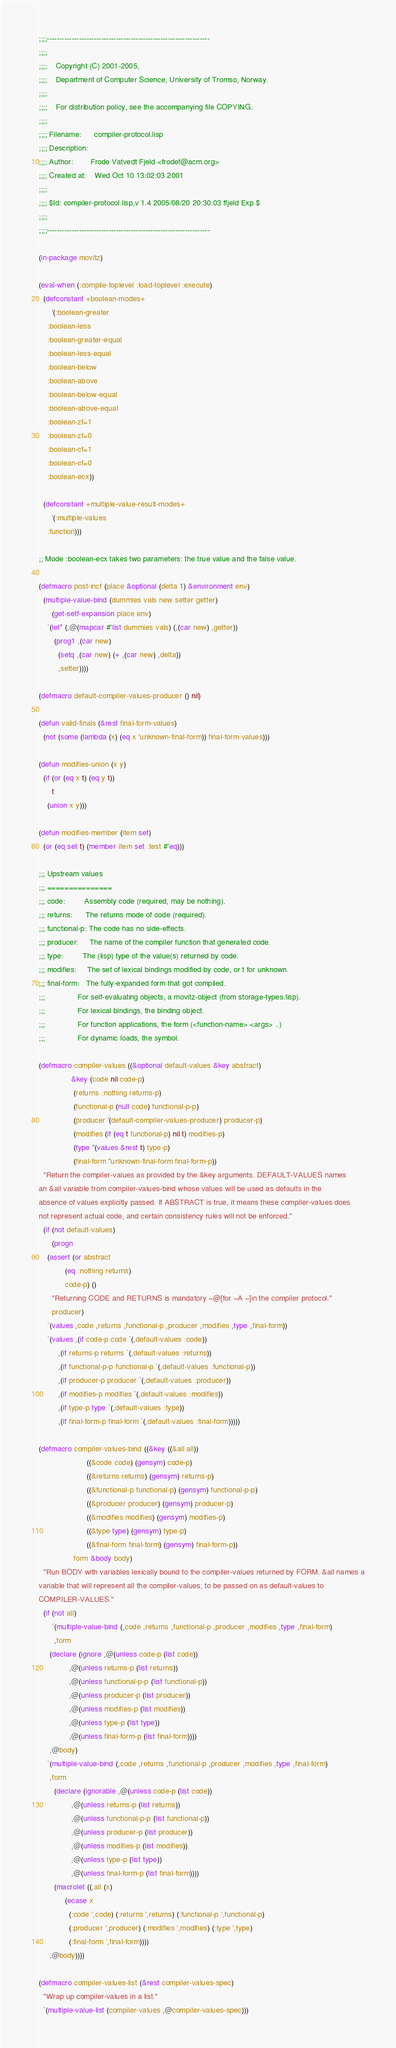Convert code to text. <code><loc_0><loc_0><loc_500><loc_500><_Lisp_>;;;;------------------------------------------------------------------
;;;; 
;;;;    Copyright (C) 2001-2005, 
;;;;    Department of Computer Science, University of Tromso, Norway.
;;;; 
;;;;    For distribution policy, see the accompanying file COPYING.
;;;; 
;;;; Filename:      compiler-protocol.lisp
;;;; Description:   
;;;; Author:        Frode Vatvedt Fjeld <frodef@acm.org>
;;;; Created at:    Wed Oct 10 13:02:03 2001
;;;;                
;;;; $Id: compiler-protocol.lisp,v 1.4 2005/08/20 20:30:03 ffjeld Exp $
;;;;                
;;;;------------------------------------------------------------------

(in-package movitz)

(eval-when (:compile-toplevel :load-toplevel :execute)
  (defconstant +boolean-modes+
      '(:boolean-greater
	:boolean-less
	:boolean-greater-equal
	:boolean-less-equal
	:boolean-below
	:boolean-above
	:boolean-below-equal
	:boolean-above-equal
	:boolean-zf=1
	:boolean-zf=0
	:boolean-cf=1
	:boolean-cf=0
	:boolean-ecx))
  
  (defconstant +multiple-value-result-modes+
      '(:multiple-values
	:function)))

;; Mode :boolean-ecx takes two parameters: the true value and the false value.

(defmacro post-incf (place &optional (delta 1) &environment env)
  (multiple-value-bind (dummies vals new setter getter)
      (get-setf-expansion place env)
    `(let* (,@(mapcar #'list dummies vals) (,(car new) ,getter))
       (prog1 ,(car new)
         (setq ,(car new) (+ ,(car new) ,delta))
         ,setter))))

(defmacro default-compiler-values-producer () nil)

(defun valid-finals (&rest final-form-values)
  (not (some (lambda (x) (eq x 'unknown-final-form)) final-form-values)))

(defun modifies-union (x y)
  (if (or (eq x t) (eq y t))
      t
    (union x y)))

(defun modifies-member (item set)
  (or (eq set t) (member item set :test #'eq)))

;;; Upstream values
;;; ===============
;;; code:         Assembly code (required, may be nothing).
;;; returns:      The returns mode of code (required).
;;; functional-p: The code has no side-effects.
;;; producer:     The name of the compiler function that generated code.
;;; type:         The (lisp) type of the value(s) returned by code.
;;; modifies:     The set of lexical bindings modified by code, or t for unknown.
;;; final-form:   The fully-expanded form that got compiled.
;;;               For self-evaluating objects, a movitz-object (from storage-types.lisp).
;;;               For lexical bindings, the binding object.
;;;               For function applications, the form (<function-name> <args> ..)
;;;               For dynamic loads, the symbol.

(defmacro compiler-values ((&optional default-values &key abstract)
			   &key (code nil code-p)
				(returns :nothing returns-p)
				(functional-p (null code) functional-p-p)
				(producer '(default-compiler-values-producer) producer-p)
				(modifies (if (eq t functional-p) nil t) modifies-p)
				(type ''(values &rest t) type-p)
				(final-form ''unknown-final-form final-form-p))
  "Return the compiler-values as provided by the &key arguments. DEFAULT-VALUES names
an &all variable from compiler-values-bind whose values will be used as defaults in the
absence of values explicitly passed. If ABSTRACT is true, it means these compiler-values does
not represent actual code, and certain consistency rules will not be enforced."
  (if (not default-values)
      (progn
	(assert (or abstract
		    (eq :nothing returns)
		    code-p) ()
	  "Returning CODE and RETURNS is mandatory ~@[for ~A ~]in the compiler protocol."
	  producer)
	`(values ,code ,returns ,functional-p ,producer ,modifies ,type ,final-form))
    `(values ,(if code-p code `(,default-values :code))
	     ,(if returns-p returns `(,default-values :returns))
	     ,(if functional-p-p functional-p `(,default-values :functional-p))
	     ,(if producer-p producer `(,default-values :producer))
	     ,(if modifies-p modifies `(,default-values :modifies))
	     ,(if type-p type `(,default-values :type))
	     ,(if final-form-p final-form `(,default-values :final-form)))))

(defmacro compiler-values-bind ((&key ((&all all))
				      ((&code code) (gensym) code-p)
				      ((&returns returns) (gensym) returns-p)
				      ((&functional-p functional-p) (gensym) functional-p-p)
				      ((&producer producer) (gensym) producer-p)
				      ((&modifies modifies) (gensym) modifies-p)
				      ((&type type) (gensym) type-p)
				      ((&final-form final-form) (gensym) final-form-p))
				form &body body)
  "Run BODY with variables lexically bound to the compiler-values returned by FORM. &all names a
variable that will represent all the compiler-values, to be passed on as default-values to
COMPILER-VALUES."
  (if (not all)
      `(multiple-value-bind (,code ,returns ,functional-p ,producer ,modifies ,type ,final-form)
	   ,form
	 (declare (ignore ,@(unless code-p (list code))
			  ,@(unless returns-p (list returns))
			  ,@(unless functional-p-p (list functional-p))
			  ,@(unless producer-p (list producer))
			  ,@(unless modifies-p (list modifies))
			  ,@(unless type-p (list type))
			  ,@(unless final-form-p (list final-form))))
	 ,@body)
    `(multiple-value-bind (,code ,returns ,functional-p ,producer ,modifies ,type ,final-form)
	 ,form
       (declare (ignorable ,@(unless code-p (list code))
			   ,@(unless returns-p (list returns))
			   ,@(unless functional-p-p (list functional-p))
			   ,@(unless producer-p (list producer))
			   ,@(unless modifies-p (list modifies))
			   ,@(unless type-p (list type))
			   ,@(unless final-form-p (list final-form))))
       (macrolet ((,all (x)
		    (ecase x
		      (:code ',code) (:returns ',returns) (:functional-p ',functional-p)
		      (:producer ',producer) (:modifies ',modifies) (:type ',type)
		      (:final-form ',final-form))))
	 ,@body))))

(defmacro compiler-values-list (&rest compiler-values-spec)
  "Wrap up compiler-values in a list."
  `(multiple-value-list (compiler-values ,@compiler-values-spec)))
</code> 